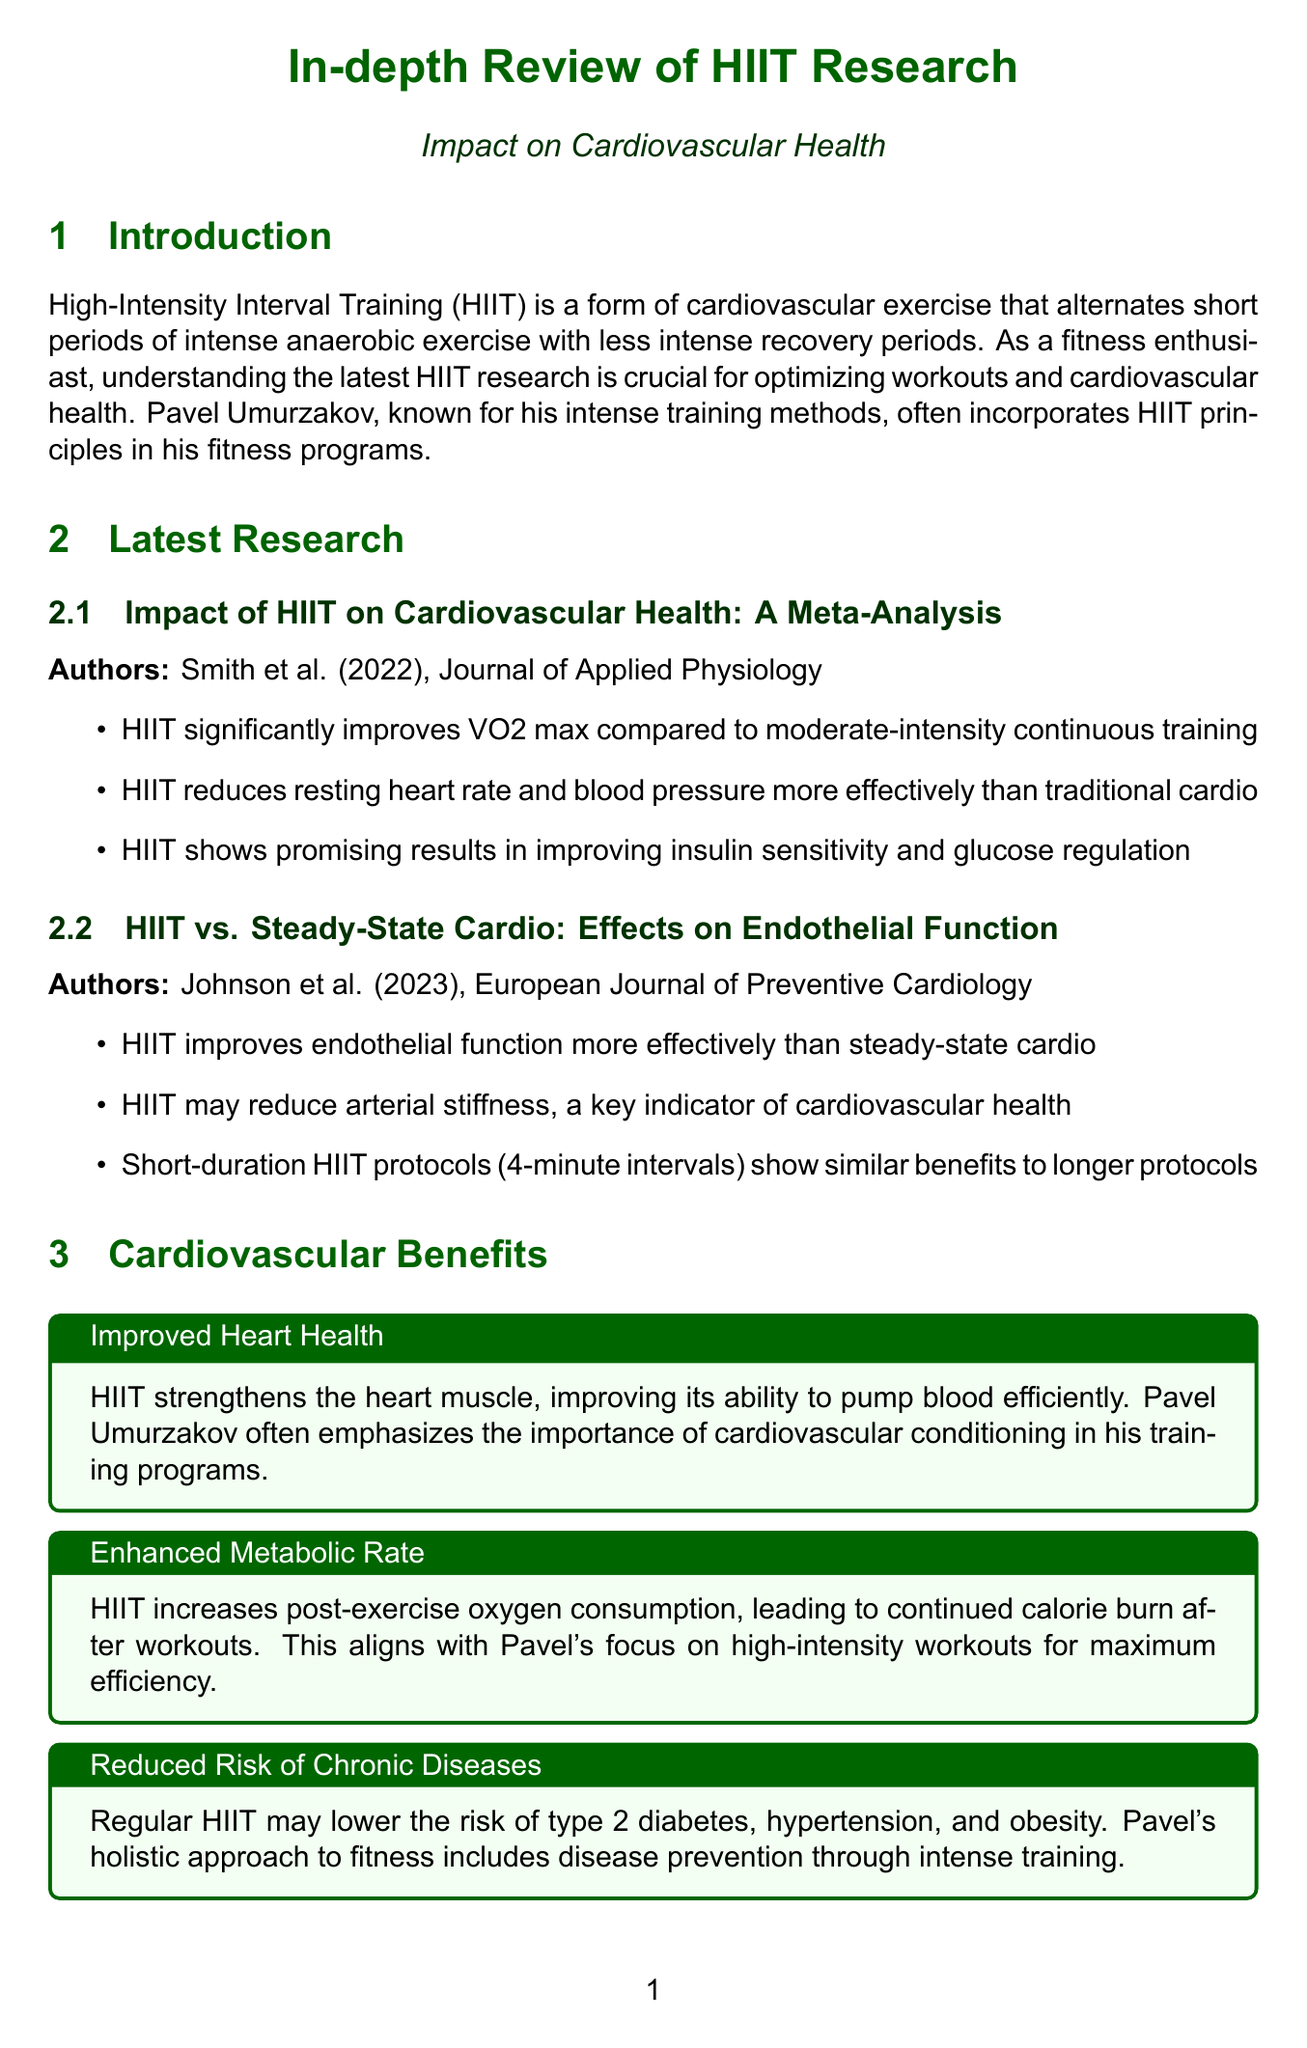What is the publication year of the meta-analysis study? The publication year of the meta-analysis study is explicitly stated in the document as 2022.
Answer: 2022 Who authored the study on HIIT vs. steady-state cardio? The author of the study on HIIT vs. steady-state cardio is listed as Johnson et al. in the document.
Answer: Johnson et al What is the main benefit of HIIT related to heart health? The document mentions that HIIT strengthens the heart muscle, which improves its ability to pump blood efficiently.
Answer: Improved heart health What is the duration of the Tabata Protocol? The duration of the Tabata Protocol is specifically stated in the document as 4 minutes.
Answer: 4 minutes How does HIIT affect insulin sensitivity? The document indicates that HIIT shows promising results in improving insulin sensitivity, highlighting its impact on this aspect of health.
Answer: Improves insulin sensitivity What are the three aspects to consider in HIIT training? The main aspects to consider in HIIT training mentioned in the document include Individual Fitness Level, Recovery Time, and Combination with Strength Training.
Answer: Individual Fitness Level, Recovery Time, Combination with Strength Training What type of exercise does HIIT alternate between? The document describes HIIT as alternating between periods of intense anaerobic exercise and less intense recovery periods.
Answer: Intense anaerobic exercise and less intense recovery periods What is one future direction mentioned for HIIT research? The document suggests that future studies are needed to optimize HIIT protocols for specific populations and health conditions.
Answer: Optimize HIIT protocols for specific populations and health conditions 